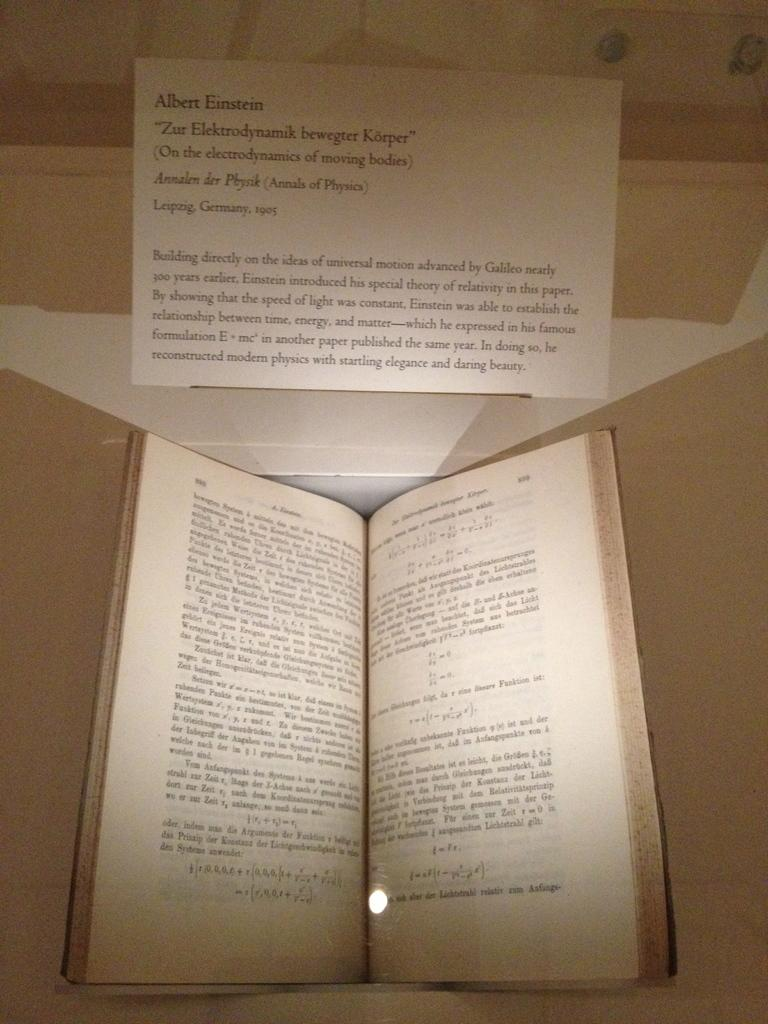<image>
Relay a brief, clear account of the picture shown. open book from 1905 by Albert Einstein on display 